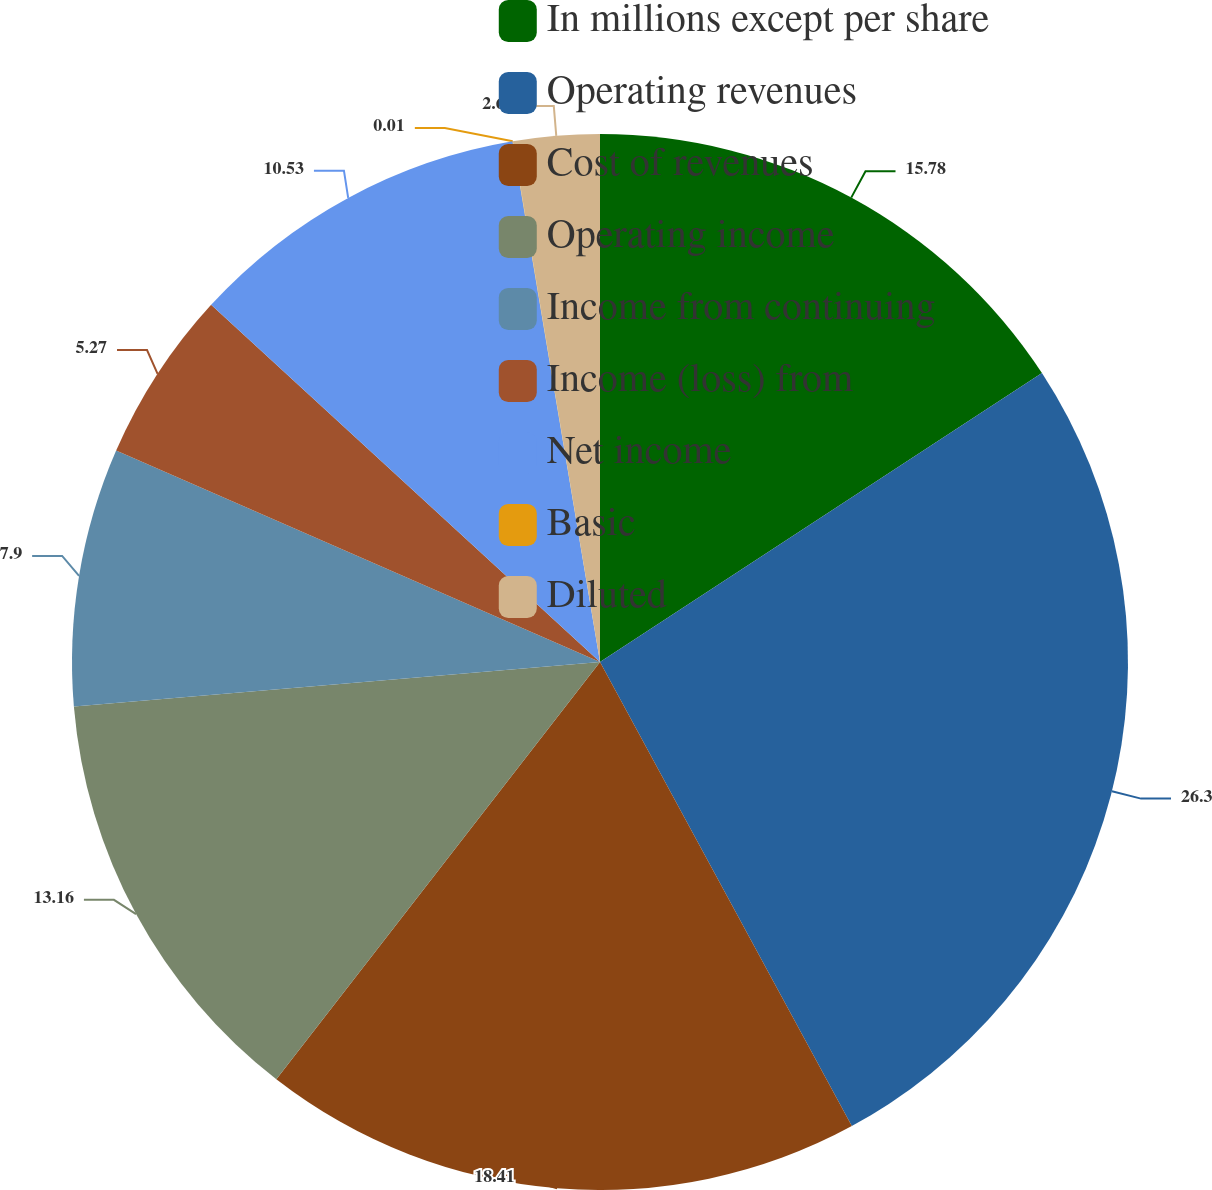<chart> <loc_0><loc_0><loc_500><loc_500><pie_chart><fcel>In millions except per share<fcel>Operating revenues<fcel>Cost of revenues<fcel>Operating income<fcel>Income from continuing<fcel>Income (loss) from<fcel>Net income<fcel>Basic<fcel>Diluted<nl><fcel>15.79%<fcel>26.31%<fcel>18.42%<fcel>13.16%<fcel>7.9%<fcel>5.27%<fcel>10.53%<fcel>0.01%<fcel>2.64%<nl></chart> 